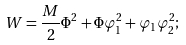Convert formula to latex. <formula><loc_0><loc_0><loc_500><loc_500>W = \frac { M } { 2 } \Phi ^ { 2 } + \Phi \varphi _ { 1 } ^ { 2 } + \varphi _ { 1 } \varphi _ { 2 } ^ { 2 } ;</formula> 